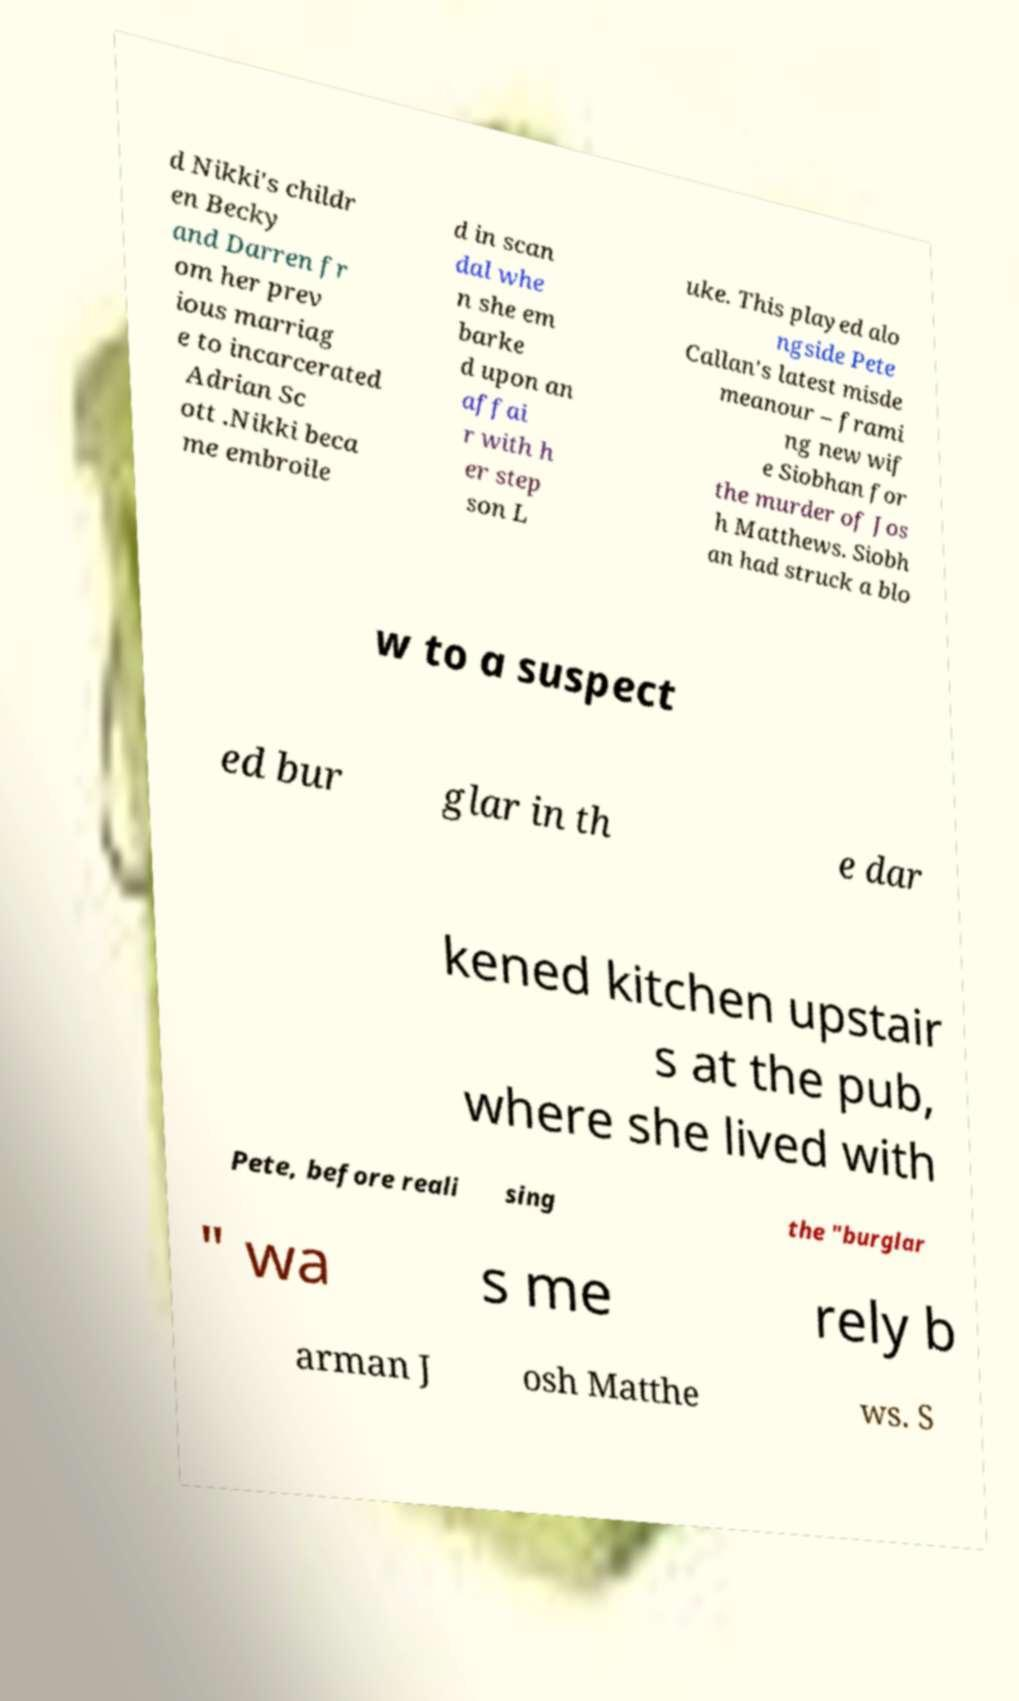Please read and relay the text visible in this image. What does it say? d Nikki's childr en Becky and Darren fr om her prev ious marriag e to incarcerated Adrian Sc ott .Nikki beca me embroile d in scan dal whe n she em barke d upon an affai r with h er step son L uke. This played alo ngside Pete Callan's latest misde meanour – frami ng new wif e Siobhan for the murder of Jos h Matthews. Siobh an had struck a blo w to a suspect ed bur glar in th e dar kened kitchen upstair s at the pub, where she lived with Pete, before reali sing the "burglar " wa s me rely b arman J osh Matthe ws. S 